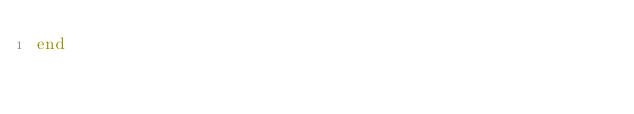<code> <loc_0><loc_0><loc_500><loc_500><_Ruby_>end
</code> 